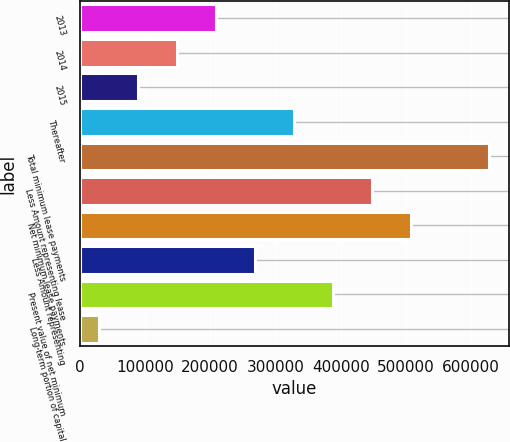Convert chart. <chart><loc_0><loc_0><loc_500><loc_500><bar_chart><fcel>2013<fcel>2014<fcel>2015<fcel>Thereafter<fcel>Total minimum lease payments<fcel>Less Amount representing lease<fcel>Net minimum lease payments<fcel>Less Amount representing<fcel>Present value of net minimum<fcel>Long-term portion of capital<nl><fcel>208746<fcel>149002<fcel>89258.7<fcel>328234<fcel>626952<fcel>447721<fcel>507465<fcel>268490<fcel>387977<fcel>29515<nl></chart> 